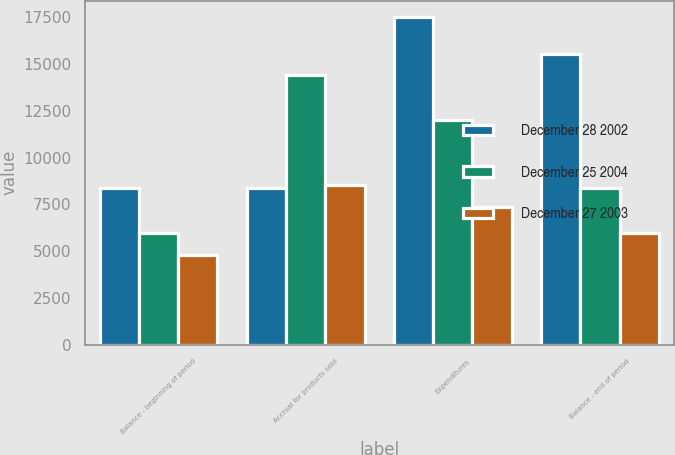Convert chart to OTSL. <chart><loc_0><loc_0><loc_500><loc_500><stacked_bar_chart><ecel><fcel>Balance - beginning of period<fcel>Accrual for products sold<fcel>Expenditures<fcel>Balance - end of period<nl><fcel>December 28 2002<fcel>8399<fcel>8399<fcel>17503<fcel>15518<nl><fcel>December 25 2004<fcel>5949<fcel>14429<fcel>11979<fcel>8399<nl><fcel>December 27 2003<fcel>4777<fcel>8520<fcel>7348<fcel>5949<nl></chart> 